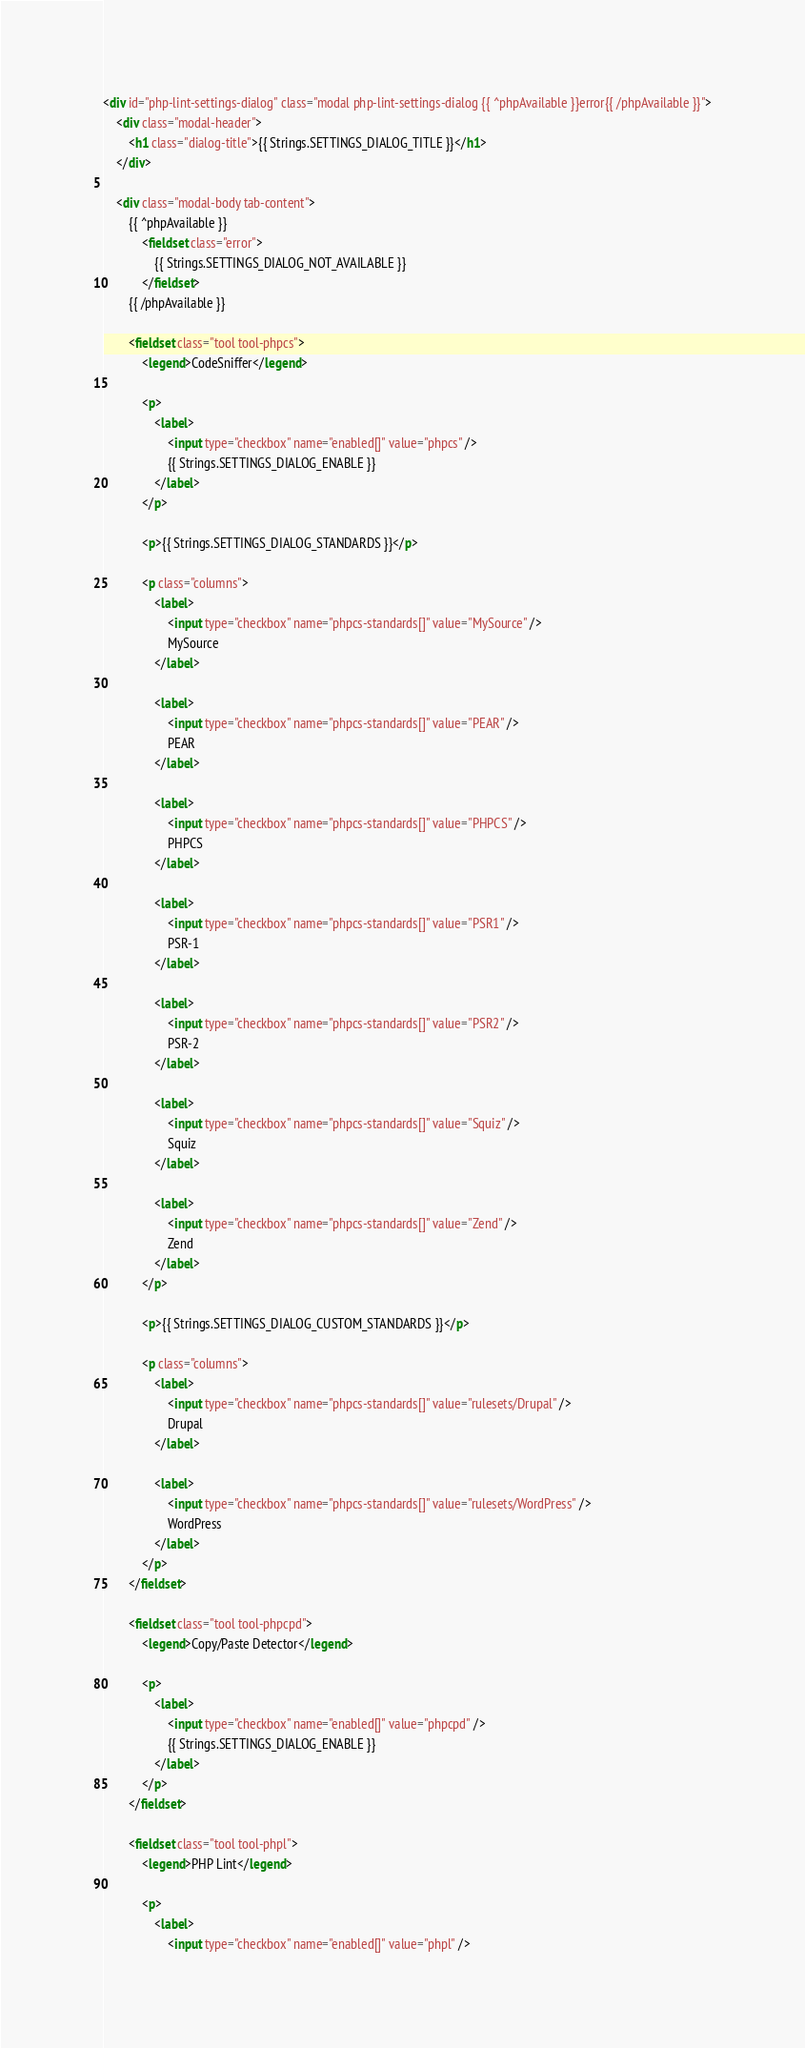Convert code to text. <code><loc_0><loc_0><loc_500><loc_500><_HTML_><div id="php-lint-settings-dialog" class="modal php-lint-settings-dialog {{ ^phpAvailable }}error{{ /phpAvailable }}">
	<div class="modal-header">
		<h1 class="dialog-title">{{ Strings.SETTINGS_DIALOG_TITLE }}</h1>
	</div>
	
	<div class="modal-body tab-content">
		{{ ^phpAvailable }}
			<fieldset class="error">
				{{ Strings.SETTINGS_DIALOG_NOT_AVAILABLE }}
			</fieldset>
		{{ /phpAvailable }}
		
		<fieldset class="tool tool-phpcs">
			<legend>CodeSniffer</legend>
			
			<p>
				<label>
					<input type="checkbox" name="enabled[]" value="phpcs" />
					{{ Strings.SETTINGS_DIALOG_ENABLE }}
				</label>
			</p>
			
			<p>{{ Strings.SETTINGS_DIALOG_STANDARDS }}</p>
			
			<p class="columns">
				<label>
					<input type="checkbox" name="phpcs-standards[]" value="MySource" />
					MySource
				</label>
				
				<label>
					<input type="checkbox" name="phpcs-standards[]" value="PEAR" />
					PEAR
				</label>
				
				<label>
					<input type="checkbox" name="phpcs-standards[]" value="PHPCS" />
					PHPCS
				</label>
				
				<label>
					<input type="checkbox" name="phpcs-standards[]" value="PSR1" />
					PSR-1
				</label>
				
				<label>
					<input type="checkbox" name="phpcs-standards[]" value="PSR2" />
					PSR-2
				</label>
				
				<label>
					<input type="checkbox" name="phpcs-standards[]" value="Squiz" />
					Squiz
				</label>
				
				<label>
					<input type="checkbox" name="phpcs-standards[]" value="Zend" />
					Zend
				</label>
			</p>
			
			<p>{{ Strings.SETTINGS_DIALOG_CUSTOM_STANDARDS }}</p>
			
			<p class="columns">
				<label>
					<input type="checkbox" name="phpcs-standards[]" value="rulesets/Drupal" />
					Drupal
				</label>
				
				<label>
					<input type="checkbox" name="phpcs-standards[]" value="rulesets/WordPress" />
					WordPress
				</label>
			</p>
		</fieldset>
		
		<fieldset class="tool tool-phpcpd">
			<legend>Copy/Paste Detector</legend>
			
			<p>
				<label>
					<input type="checkbox" name="enabled[]" value="phpcpd" />
					{{ Strings.SETTINGS_DIALOG_ENABLE }}
				</label>
			</p>
		</fieldset>
		
		<fieldset class="tool tool-phpl">
			<legend>PHP Lint</legend>
			
			<p>
				<label>
					<input type="checkbox" name="enabled[]" value="phpl" /></code> 